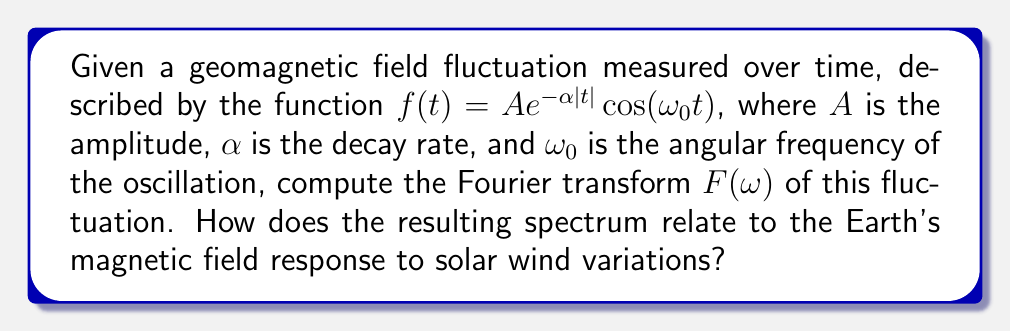Could you help me with this problem? To compute the Fourier transform of the given geomagnetic field fluctuation, we'll follow these steps:

1) The Fourier transform is defined as:
   $$F(\omega) = \int_{-\infty}^{\infty} f(t) e^{-i\omega t} dt$$

2) Substituting our function $f(t) = A e^{-\alpha|t|} \cos(\omega_0 t)$:
   $$F(\omega) = A \int_{-\infty}^{\infty} e^{-\alpha|t|} \cos(\omega_0 t) e^{-i\omega t} dt$$

3) Using Euler's formula, $\cos(\omega_0 t) = \frac{1}{2}(e^{i\omega_0 t} + e^{-i\omega_0 t})$:
   $$F(\omega) = \frac{A}{2} \int_{-\infty}^{\infty} e^{-\alpha|t|} (e^{i\omega_0 t} + e^{-i\omega_0 t}) e^{-i\omega t} dt$$

4) This can be split into two integrals:
   $$F(\omega) = \frac{A}{2} \int_{-\infty}^{\infty} e^{-\alpha|t|} e^{i(\omega_0-\omega)t} dt + \frac{A}{2} \int_{-\infty}^{\infty} e^{-\alpha|t|} e^{-i(\omega_0+\omega)t} dt$$

5) Each of these integrals has the form of a Fourier transform of an exponential decay function, which has a known solution:
   $$\int_{-\infty}^{\infty} e^{-\alpha|t|} e^{-i\beta t} dt = \frac{2\alpha}{\alpha^2 + \beta^2}$$

6) Applying this to our integrals:
   $$F(\omega) = \frac{A}{2} \cdot \frac{2\alpha}{\alpha^2 + (\omega_0-\omega)^2} + \frac{A}{2} \cdot \frac{2\alpha}{\alpha^2 + (\omega_0+\omega)^2}$$

7) Simplifying:
   $$F(\omega) = A\alpha \left(\frac{1}{\alpha^2 + (\omega_0-\omega)^2} + \frac{1}{\alpha^2 + (\omega_0+\omega)^2}\right)$$

This spectrum shows two peaks centered at $\omega = \pm\omega_0$, with the width of the peaks determined by $\alpha$. This relates to the Earth's magnetic field response to solar wind variations as follows:

- The central frequencies ($\pm\omega_0$) correspond to the dominant oscillation frequency of the geomagnetic field fluctuations, which can be linked to specific types of solar wind-magnetosphere interactions.
- The width of the peaks (determined by $\alpha$) indicates the persistence of these fluctuations, with narrower peaks suggesting longer-lasting oscillations.
- The overall shape (two symmetric peaks) is characteristic of amplitude-modulated signals, which is consistent with the way solar wind variations often modulate Earth's magnetic field.
Answer: $F(\omega) = A\alpha \left(\frac{1}{\alpha^2 + (\omega_0-\omega)^2} + \frac{1}{\alpha^2 + (\omega_0+\omega)^2}\right)$ 